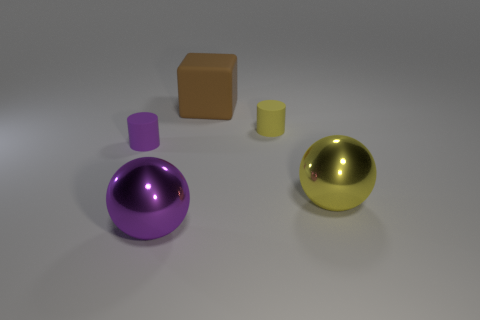Do the objects give any indication of their scale or size in relation to each other? Yes, the objects are arranged in such a manner that we can infer their approximate relative size. The purple and gold spheres are roughly the same size, suggesting that they might be used to compare weights or materials under similar volumes. The cube and cylinder are smaller and seem to provide visual contrast in shape and potentially in tactile textures if one were to physically interact with them. 